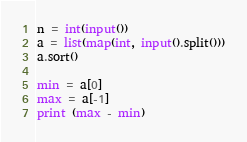<code> <loc_0><loc_0><loc_500><loc_500><_Python_>n = int(input())
a = list(map(int, input().split()))
a.sort()

min = a[0]
max = a[-1]
print (max - min)</code> 